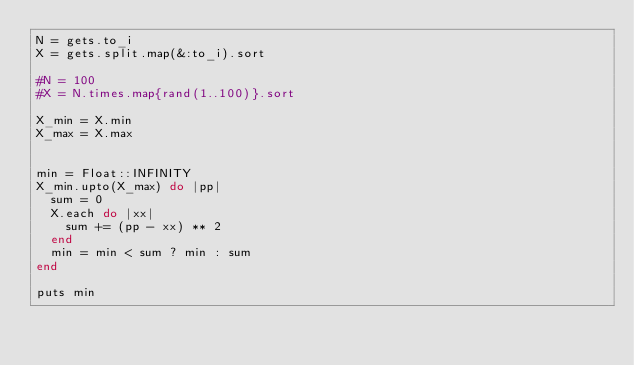Convert code to text. <code><loc_0><loc_0><loc_500><loc_500><_Ruby_>N = gets.to_i
X = gets.split.map(&:to_i).sort

#N = 100
#X = N.times.map{rand(1..100)}.sort

X_min = X.min
X_max = X.max


min = Float::INFINITY
X_min.upto(X_max) do |pp|
  sum = 0
  X.each do |xx|
    sum += (pp - xx) ** 2
  end
  min = min < sum ? min : sum
end

puts min</code> 